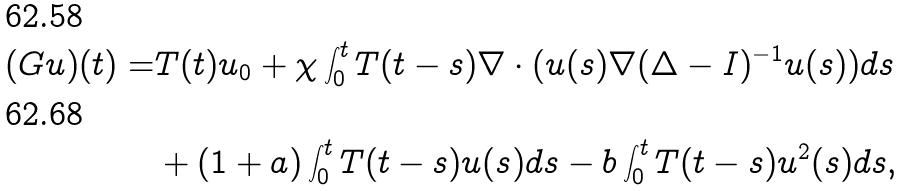Convert formula to latex. <formula><loc_0><loc_0><loc_500><loc_500>( G u ) ( t ) = & T ( t ) u _ { 0 } + \chi \int _ { 0 } ^ { t } T ( t - s ) \nabla \cdot ( u ( s ) \nabla ( \Delta - I ) ^ { - 1 } u ( s ) ) d s \\ & + ( 1 + a ) \int _ { 0 } ^ { t } T ( t - s ) u ( s ) d s - b \int _ { 0 } ^ { t } T ( t - s ) u ^ { 2 } ( s ) d s ,</formula> 